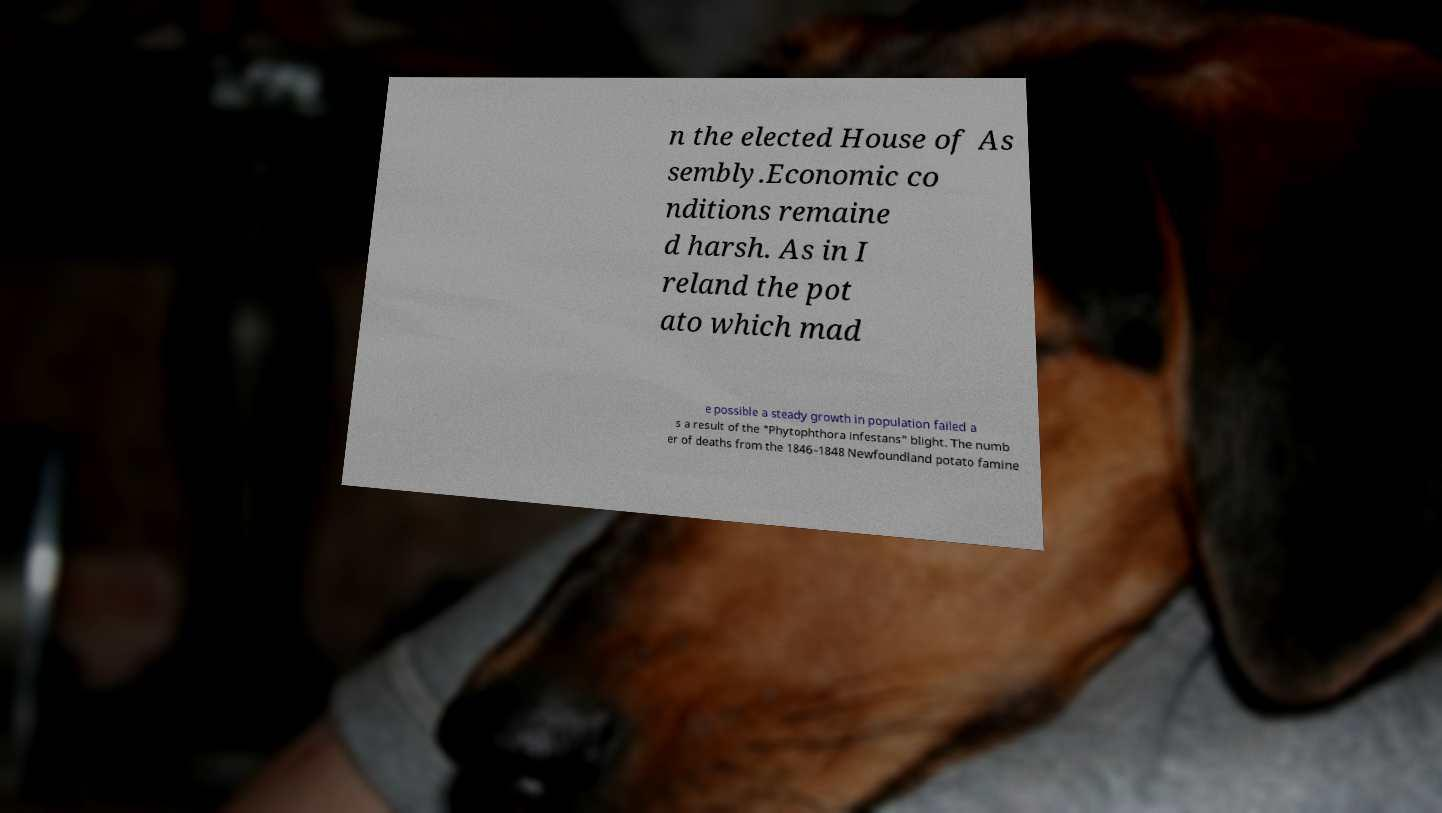Could you assist in decoding the text presented in this image and type it out clearly? n the elected House of As sembly.Economic co nditions remaine d harsh. As in I reland the pot ato which mad e possible a steady growth in population failed a s a result of the "Phytophthora infestans" blight. The numb er of deaths from the 1846–1848 Newfoundland potato famine 